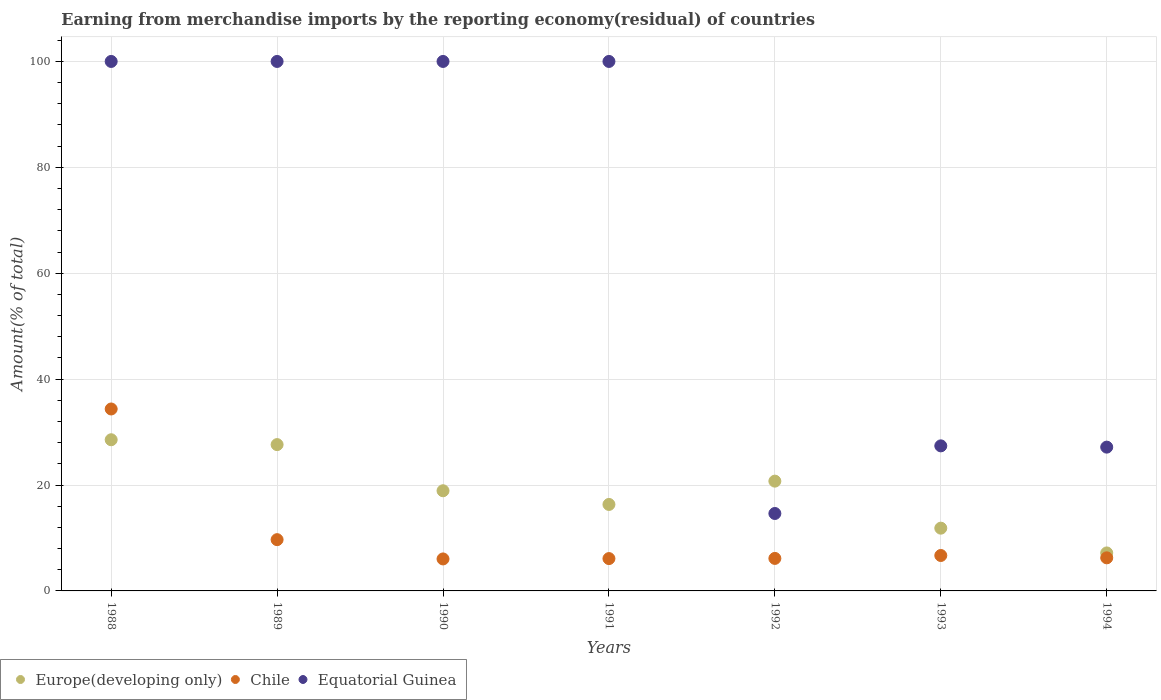How many different coloured dotlines are there?
Give a very brief answer. 3. Is the number of dotlines equal to the number of legend labels?
Offer a very short reply. Yes. What is the percentage of amount earned from merchandise imports in Europe(developing only) in 1993?
Offer a terse response. 11.85. Across all years, what is the maximum percentage of amount earned from merchandise imports in Chile?
Ensure brevity in your answer.  34.36. Across all years, what is the minimum percentage of amount earned from merchandise imports in Europe(developing only)?
Offer a terse response. 7.17. What is the total percentage of amount earned from merchandise imports in Europe(developing only) in the graph?
Keep it short and to the point. 131.2. What is the difference between the percentage of amount earned from merchandise imports in Equatorial Guinea in 1991 and that in 1994?
Offer a very short reply. 72.84. What is the difference between the percentage of amount earned from merchandise imports in Europe(developing only) in 1993 and the percentage of amount earned from merchandise imports in Chile in 1991?
Offer a terse response. 5.75. What is the average percentage of amount earned from merchandise imports in Equatorial Guinea per year?
Offer a very short reply. 67.03. In the year 1990, what is the difference between the percentage of amount earned from merchandise imports in Equatorial Guinea and percentage of amount earned from merchandise imports in Chile?
Provide a succinct answer. 93.96. What is the ratio of the percentage of amount earned from merchandise imports in Europe(developing only) in 1988 to that in 1991?
Ensure brevity in your answer.  1.75. Is the percentage of amount earned from merchandise imports in Europe(developing only) in 1989 less than that in 1993?
Offer a terse response. No. What is the difference between the highest and the second highest percentage of amount earned from merchandise imports in Chile?
Your answer should be compact. 24.68. What is the difference between the highest and the lowest percentage of amount earned from merchandise imports in Chile?
Give a very brief answer. 28.32. In how many years, is the percentage of amount earned from merchandise imports in Europe(developing only) greater than the average percentage of amount earned from merchandise imports in Europe(developing only) taken over all years?
Keep it short and to the point. 4. Is the sum of the percentage of amount earned from merchandise imports in Europe(developing only) in 1988 and 1991 greater than the maximum percentage of amount earned from merchandise imports in Equatorial Guinea across all years?
Provide a succinct answer. No. Is it the case that in every year, the sum of the percentage of amount earned from merchandise imports in Europe(developing only) and percentage of amount earned from merchandise imports in Equatorial Guinea  is greater than the percentage of amount earned from merchandise imports in Chile?
Offer a very short reply. Yes. Does the percentage of amount earned from merchandise imports in Equatorial Guinea monotonically increase over the years?
Ensure brevity in your answer.  No. How many dotlines are there?
Your answer should be very brief. 3. How many years are there in the graph?
Your answer should be very brief. 7. Where does the legend appear in the graph?
Provide a succinct answer. Bottom left. How are the legend labels stacked?
Provide a short and direct response. Horizontal. What is the title of the graph?
Your answer should be compact. Earning from merchandise imports by the reporting economy(residual) of countries. Does "Lithuania" appear as one of the legend labels in the graph?
Provide a succinct answer. No. What is the label or title of the Y-axis?
Your response must be concise. Amount(% of total). What is the Amount(% of total) in Europe(developing only) in 1988?
Provide a succinct answer. 28.55. What is the Amount(% of total) of Chile in 1988?
Provide a short and direct response. 34.36. What is the Amount(% of total) in Equatorial Guinea in 1988?
Your answer should be compact. 100. What is the Amount(% of total) of Europe(developing only) in 1989?
Your response must be concise. 27.64. What is the Amount(% of total) in Chile in 1989?
Your answer should be compact. 9.68. What is the Amount(% of total) of Equatorial Guinea in 1989?
Offer a terse response. 100. What is the Amount(% of total) of Europe(developing only) in 1990?
Provide a succinct answer. 18.92. What is the Amount(% of total) in Chile in 1990?
Your answer should be compact. 6.04. What is the Amount(% of total) in Equatorial Guinea in 1990?
Give a very brief answer. 100. What is the Amount(% of total) in Europe(developing only) in 1991?
Offer a terse response. 16.33. What is the Amount(% of total) of Chile in 1991?
Your answer should be compact. 6.11. What is the Amount(% of total) in Europe(developing only) in 1992?
Your answer should be compact. 20.73. What is the Amount(% of total) of Chile in 1992?
Keep it short and to the point. 6.14. What is the Amount(% of total) in Equatorial Guinea in 1992?
Provide a short and direct response. 14.62. What is the Amount(% of total) in Europe(developing only) in 1993?
Keep it short and to the point. 11.85. What is the Amount(% of total) in Chile in 1993?
Make the answer very short. 6.69. What is the Amount(% of total) of Equatorial Guinea in 1993?
Your answer should be compact. 27.4. What is the Amount(% of total) in Europe(developing only) in 1994?
Keep it short and to the point. 7.17. What is the Amount(% of total) of Chile in 1994?
Provide a short and direct response. 6.25. What is the Amount(% of total) in Equatorial Guinea in 1994?
Keep it short and to the point. 27.16. Across all years, what is the maximum Amount(% of total) of Europe(developing only)?
Ensure brevity in your answer.  28.55. Across all years, what is the maximum Amount(% of total) of Chile?
Give a very brief answer. 34.36. Across all years, what is the maximum Amount(% of total) of Equatorial Guinea?
Provide a short and direct response. 100. Across all years, what is the minimum Amount(% of total) of Europe(developing only)?
Your response must be concise. 7.17. Across all years, what is the minimum Amount(% of total) of Chile?
Your response must be concise. 6.04. Across all years, what is the minimum Amount(% of total) in Equatorial Guinea?
Give a very brief answer. 14.62. What is the total Amount(% of total) of Europe(developing only) in the graph?
Your answer should be very brief. 131.2. What is the total Amount(% of total) in Chile in the graph?
Keep it short and to the point. 75.27. What is the total Amount(% of total) in Equatorial Guinea in the graph?
Provide a succinct answer. 469.18. What is the difference between the Amount(% of total) of Europe(developing only) in 1988 and that in 1989?
Provide a short and direct response. 0.92. What is the difference between the Amount(% of total) of Chile in 1988 and that in 1989?
Make the answer very short. 24.68. What is the difference between the Amount(% of total) of Equatorial Guinea in 1988 and that in 1989?
Provide a short and direct response. 0. What is the difference between the Amount(% of total) of Europe(developing only) in 1988 and that in 1990?
Offer a very short reply. 9.63. What is the difference between the Amount(% of total) in Chile in 1988 and that in 1990?
Offer a terse response. 28.32. What is the difference between the Amount(% of total) in Europe(developing only) in 1988 and that in 1991?
Offer a very short reply. 12.22. What is the difference between the Amount(% of total) in Chile in 1988 and that in 1991?
Offer a very short reply. 28.25. What is the difference between the Amount(% of total) in Equatorial Guinea in 1988 and that in 1991?
Your answer should be very brief. 0. What is the difference between the Amount(% of total) of Europe(developing only) in 1988 and that in 1992?
Provide a short and direct response. 7.82. What is the difference between the Amount(% of total) of Chile in 1988 and that in 1992?
Your answer should be compact. 28.22. What is the difference between the Amount(% of total) in Equatorial Guinea in 1988 and that in 1992?
Ensure brevity in your answer.  85.38. What is the difference between the Amount(% of total) in Europe(developing only) in 1988 and that in 1993?
Your response must be concise. 16.7. What is the difference between the Amount(% of total) in Chile in 1988 and that in 1993?
Make the answer very short. 27.67. What is the difference between the Amount(% of total) of Equatorial Guinea in 1988 and that in 1993?
Give a very brief answer. 72.6. What is the difference between the Amount(% of total) of Europe(developing only) in 1988 and that in 1994?
Provide a succinct answer. 21.38. What is the difference between the Amount(% of total) of Chile in 1988 and that in 1994?
Your response must be concise. 28.11. What is the difference between the Amount(% of total) of Equatorial Guinea in 1988 and that in 1994?
Offer a very short reply. 72.84. What is the difference between the Amount(% of total) in Europe(developing only) in 1989 and that in 1990?
Offer a very short reply. 8.72. What is the difference between the Amount(% of total) in Chile in 1989 and that in 1990?
Keep it short and to the point. 3.64. What is the difference between the Amount(% of total) in Equatorial Guinea in 1989 and that in 1990?
Offer a terse response. 0. What is the difference between the Amount(% of total) in Europe(developing only) in 1989 and that in 1991?
Offer a terse response. 11.3. What is the difference between the Amount(% of total) of Chile in 1989 and that in 1991?
Your answer should be very brief. 3.58. What is the difference between the Amount(% of total) in Europe(developing only) in 1989 and that in 1992?
Provide a short and direct response. 6.9. What is the difference between the Amount(% of total) in Chile in 1989 and that in 1992?
Offer a terse response. 3.54. What is the difference between the Amount(% of total) in Equatorial Guinea in 1989 and that in 1992?
Make the answer very short. 85.38. What is the difference between the Amount(% of total) in Europe(developing only) in 1989 and that in 1993?
Provide a short and direct response. 15.78. What is the difference between the Amount(% of total) in Chile in 1989 and that in 1993?
Your answer should be very brief. 2.99. What is the difference between the Amount(% of total) in Equatorial Guinea in 1989 and that in 1993?
Your answer should be very brief. 72.6. What is the difference between the Amount(% of total) in Europe(developing only) in 1989 and that in 1994?
Your response must be concise. 20.46. What is the difference between the Amount(% of total) of Chile in 1989 and that in 1994?
Your answer should be compact. 3.43. What is the difference between the Amount(% of total) in Equatorial Guinea in 1989 and that in 1994?
Your answer should be very brief. 72.84. What is the difference between the Amount(% of total) of Europe(developing only) in 1990 and that in 1991?
Provide a succinct answer. 2.59. What is the difference between the Amount(% of total) of Chile in 1990 and that in 1991?
Offer a very short reply. -0.07. What is the difference between the Amount(% of total) of Equatorial Guinea in 1990 and that in 1991?
Offer a terse response. 0. What is the difference between the Amount(% of total) in Europe(developing only) in 1990 and that in 1992?
Ensure brevity in your answer.  -1.82. What is the difference between the Amount(% of total) in Chile in 1990 and that in 1992?
Keep it short and to the point. -0.1. What is the difference between the Amount(% of total) in Equatorial Guinea in 1990 and that in 1992?
Your response must be concise. 85.38. What is the difference between the Amount(% of total) in Europe(developing only) in 1990 and that in 1993?
Keep it short and to the point. 7.06. What is the difference between the Amount(% of total) in Chile in 1990 and that in 1993?
Ensure brevity in your answer.  -0.65. What is the difference between the Amount(% of total) of Equatorial Guinea in 1990 and that in 1993?
Your response must be concise. 72.6. What is the difference between the Amount(% of total) of Europe(developing only) in 1990 and that in 1994?
Your answer should be very brief. 11.74. What is the difference between the Amount(% of total) in Chile in 1990 and that in 1994?
Provide a short and direct response. -0.21. What is the difference between the Amount(% of total) of Equatorial Guinea in 1990 and that in 1994?
Offer a very short reply. 72.84. What is the difference between the Amount(% of total) of Europe(developing only) in 1991 and that in 1992?
Your answer should be compact. -4.4. What is the difference between the Amount(% of total) in Chile in 1991 and that in 1992?
Offer a terse response. -0.03. What is the difference between the Amount(% of total) in Equatorial Guinea in 1991 and that in 1992?
Give a very brief answer. 85.38. What is the difference between the Amount(% of total) in Europe(developing only) in 1991 and that in 1993?
Give a very brief answer. 4.48. What is the difference between the Amount(% of total) of Chile in 1991 and that in 1993?
Your answer should be compact. -0.58. What is the difference between the Amount(% of total) in Equatorial Guinea in 1991 and that in 1993?
Provide a succinct answer. 72.6. What is the difference between the Amount(% of total) of Europe(developing only) in 1991 and that in 1994?
Offer a terse response. 9.16. What is the difference between the Amount(% of total) in Chile in 1991 and that in 1994?
Offer a terse response. -0.14. What is the difference between the Amount(% of total) of Equatorial Guinea in 1991 and that in 1994?
Your response must be concise. 72.84. What is the difference between the Amount(% of total) of Europe(developing only) in 1992 and that in 1993?
Offer a terse response. 8.88. What is the difference between the Amount(% of total) of Chile in 1992 and that in 1993?
Provide a short and direct response. -0.55. What is the difference between the Amount(% of total) in Equatorial Guinea in 1992 and that in 1993?
Offer a very short reply. -12.77. What is the difference between the Amount(% of total) in Europe(developing only) in 1992 and that in 1994?
Provide a succinct answer. 13.56. What is the difference between the Amount(% of total) in Chile in 1992 and that in 1994?
Keep it short and to the point. -0.11. What is the difference between the Amount(% of total) in Equatorial Guinea in 1992 and that in 1994?
Give a very brief answer. -12.53. What is the difference between the Amount(% of total) of Europe(developing only) in 1993 and that in 1994?
Offer a terse response. 4.68. What is the difference between the Amount(% of total) in Chile in 1993 and that in 1994?
Your answer should be very brief. 0.44. What is the difference between the Amount(% of total) in Equatorial Guinea in 1993 and that in 1994?
Make the answer very short. 0.24. What is the difference between the Amount(% of total) of Europe(developing only) in 1988 and the Amount(% of total) of Chile in 1989?
Your answer should be very brief. 18.87. What is the difference between the Amount(% of total) in Europe(developing only) in 1988 and the Amount(% of total) in Equatorial Guinea in 1989?
Give a very brief answer. -71.45. What is the difference between the Amount(% of total) of Chile in 1988 and the Amount(% of total) of Equatorial Guinea in 1989?
Offer a terse response. -65.64. What is the difference between the Amount(% of total) in Europe(developing only) in 1988 and the Amount(% of total) in Chile in 1990?
Your answer should be compact. 22.51. What is the difference between the Amount(% of total) in Europe(developing only) in 1988 and the Amount(% of total) in Equatorial Guinea in 1990?
Ensure brevity in your answer.  -71.45. What is the difference between the Amount(% of total) in Chile in 1988 and the Amount(% of total) in Equatorial Guinea in 1990?
Offer a very short reply. -65.64. What is the difference between the Amount(% of total) of Europe(developing only) in 1988 and the Amount(% of total) of Chile in 1991?
Offer a very short reply. 22.44. What is the difference between the Amount(% of total) of Europe(developing only) in 1988 and the Amount(% of total) of Equatorial Guinea in 1991?
Keep it short and to the point. -71.45. What is the difference between the Amount(% of total) of Chile in 1988 and the Amount(% of total) of Equatorial Guinea in 1991?
Offer a terse response. -65.64. What is the difference between the Amount(% of total) in Europe(developing only) in 1988 and the Amount(% of total) in Chile in 1992?
Keep it short and to the point. 22.41. What is the difference between the Amount(% of total) in Europe(developing only) in 1988 and the Amount(% of total) in Equatorial Guinea in 1992?
Give a very brief answer. 13.93. What is the difference between the Amount(% of total) in Chile in 1988 and the Amount(% of total) in Equatorial Guinea in 1992?
Provide a succinct answer. 19.74. What is the difference between the Amount(% of total) of Europe(developing only) in 1988 and the Amount(% of total) of Chile in 1993?
Provide a short and direct response. 21.86. What is the difference between the Amount(% of total) of Europe(developing only) in 1988 and the Amount(% of total) of Equatorial Guinea in 1993?
Your answer should be very brief. 1.16. What is the difference between the Amount(% of total) in Chile in 1988 and the Amount(% of total) in Equatorial Guinea in 1993?
Offer a very short reply. 6.97. What is the difference between the Amount(% of total) of Europe(developing only) in 1988 and the Amount(% of total) of Chile in 1994?
Provide a succinct answer. 22.3. What is the difference between the Amount(% of total) in Europe(developing only) in 1988 and the Amount(% of total) in Equatorial Guinea in 1994?
Provide a short and direct response. 1.39. What is the difference between the Amount(% of total) in Chile in 1988 and the Amount(% of total) in Equatorial Guinea in 1994?
Provide a succinct answer. 7.2. What is the difference between the Amount(% of total) in Europe(developing only) in 1989 and the Amount(% of total) in Chile in 1990?
Keep it short and to the point. 21.59. What is the difference between the Amount(% of total) in Europe(developing only) in 1989 and the Amount(% of total) in Equatorial Guinea in 1990?
Your response must be concise. -72.36. What is the difference between the Amount(% of total) of Chile in 1989 and the Amount(% of total) of Equatorial Guinea in 1990?
Provide a succinct answer. -90.32. What is the difference between the Amount(% of total) in Europe(developing only) in 1989 and the Amount(% of total) in Chile in 1991?
Offer a very short reply. 21.53. What is the difference between the Amount(% of total) in Europe(developing only) in 1989 and the Amount(% of total) in Equatorial Guinea in 1991?
Offer a very short reply. -72.36. What is the difference between the Amount(% of total) in Chile in 1989 and the Amount(% of total) in Equatorial Guinea in 1991?
Provide a succinct answer. -90.32. What is the difference between the Amount(% of total) in Europe(developing only) in 1989 and the Amount(% of total) in Chile in 1992?
Give a very brief answer. 21.5. What is the difference between the Amount(% of total) in Europe(developing only) in 1989 and the Amount(% of total) in Equatorial Guinea in 1992?
Keep it short and to the point. 13.01. What is the difference between the Amount(% of total) of Chile in 1989 and the Amount(% of total) of Equatorial Guinea in 1992?
Give a very brief answer. -4.94. What is the difference between the Amount(% of total) in Europe(developing only) in 1989 and the Amount(% of total) in Chile in 1993?
Keep it short and to the point. 20.94. What is the difference between the Amount(% of total) in Europe(developing only) in 1989 and the Amount(% of total) in Equatorial Guinea in 1993?
Give a very brief answer. 0.24. What is the difference between the Amount(% of total) in Chile in 1989 and the Amount(% of total) in Equatorial Guinea in 1993?
Your answer should be very brief. -17.71. What is the difference between the Amount(% of total) of Europe(developing only) in 1989 and the Amount(% of total) of Chile in 1994?
Make the answer very short. 21.39. What is the difference between the Amount(% of total) in Europe(developing only) in 1989 and the Amount(% of total) in Equatorial Guinea in 1994?
Ensure brevity in your answer.  0.48. What is the difference between the Amount(% of total) of Chile in 1989 and the Amount(% of total) of Equatorial Guinea in 1994?
Provide a succinct answer. -17.47. What is the difference between the Amount(% of total) of Europe(developing only) in 1990 and the Amount(% of total) of Chile in 1991?
Your answer should be very brief. 12.81. What is the difference between the Amount(% of total) in Europe(developing only) in 1990 and the Amount(% of total) in Equatorial Guinea in 1991?
Provide a succinct answer. -81.08. What is the difference between the Amount(% of total) of Chile in 1990 and the Amount(% of total) of Equatorial Guinea in 1991?
Provide a succinct answer. -93.96. What is the difference between the Amount(% of total) in Europe(developing only) in 1990 and the Amount(% of total) in Chile in 1992?
Offer a terse response. 12.78. What is the difference between the Amount(% of total) of Europe(developing only) in 1990 and the Amount(% of total) of Equatorial Guinea in 1992?
Give a very brief answer. 4.29. What is the difference between the Amount(% of total) in Chile in 1990 and the Amount(% of total) in Equatorial Guinea in 1992?
Give a very brief answer. -8.58. What is the difference between the Amount(% of total) in Europe(developing only) in 1990 and the Amount(% of total) in Chile in 1993?
Offer a very short reply. 12.23. What is the difference between the Amount(% of total) of Europe(developing only) in 1990 and the Amount(% of total) of Equatorial Guinea in 1993?
Offer a very short reply. -8.48. What is the difference between the Amount(% of total) of Chile in 1990 and the Amount(% of total) of Equatorial Guinea in 1993?
Provide a succinct answer. -21.35. What is the difference between the Amount(% of total) in Europe(developing only) in 1990 and the Amount(% of total) in Chile in 1994?
Offer a terse response. 12.67. What is the difference between the Amount(% of total) in Europe(developing only) in 1990 and the Amount(% of total) in Equatorial Guinea in 1994?
Ensure brevity in your answer.  -8.24. What is the difference between the Amount(% of total) in Chile in 1990 and the Amount(% of total) in Equatorial Guinea in 1994?
Provide a short and direct response. -21.12. What is the difference between the Amount(% of total) of Europe(developing only) in 1991 and the Amount(% of total) of Chile in 1992?
Keep it short and to the point. 10.19. What is the difference between the Amount(% of total) in Europe(developing only) in 1991 and the Amount(% of total) in Equatorial Guinea in 1992?
Make the answer very short. 1.71. What is the difference between the Amount(% of total) in Chile in 1991 and the Amount(% of total) in Equatorial Guinea in 1992?
Your answer should be very brief. -8.52. What is the difference between the Amount(% of total) in Europe(developing only) in 1991 and the Amount(% of total) in Chile in 1993?
Your answer should be compact. 9.64. What is the difference between the Amount(% of total) of Europe(developing only) in 1991 and the Amount(% of total) of Equatorial Guinea in 1993?
Keep it short and to the point. -11.06. What is the difference between the Amount(% of total) of Chile in 1991 and the Amount(% of total) of Equatorial Guinea in 1993?
Your response must be concise. -21.29. What is the difference between the Amount(% of total) in Europe(developing only) in 1991 and the Amount(% of total) in Chile in 1994?
Give a very brief answer. 10.08. What is the difference between the Amount(% of total) in Europe(developing only) in 1991 and the Amount(% of total) in Equatorial Guinea in 1994?
Your answer should be compact. -10.82. What is the difference between the Amount(% of total) of Chile in 1991 and the Amount(% of total) of Equatorial Guinea in 1994?
Your answer should be very brief. -21.05. What is the difference between the Amount(% of total) of Europe(developing only) in 1992 and the Amount(% of total) of Chile in 1993?
Offer a terse response. 14.04. What is the difference between the Amount(% of total) in Europe(developing only) in 1992 and the Amount(% of total) in Equatorial Guinea in 1993?
Make the answer very short. -6.66. What is the difference between the Amount(% of total) in Chile in 1992 and the Amount(% of total) in Equatorial Guinea in 1993?
Offer a very short reply. -21.26. What is the difference between the Amount(% of total) in Europe(developing only) in 1992 and the Amount(% of total) in Chile in 1994?
Keep it short and to the point. 14.48. What is the difference between the Amount(% of total) in Europe(developing only) in 1992 and the Amount(% of total) in Equatorial Guinea in 1994?
Offer a very short reply. -6.42. What is the difference between the Amount(% of total) in Chile in 1992 and the Amount(% of total) in Equatorial Guinea in 1994?
Offer a very short reply. -21.02. What is the difference between the Amount(% of total) in Europe(developing only) in 1993 and the Amount(% of total) in Chile in 1994?
Your answer should be compact. 5.6. What is the difference between the Amount(% of total) in Europe(developing only) in 1993 and the Amount(% of total) in Equatorial Guinea in 1994?
Keep it short and to the point. -15.3. What is the difference between the Amount(% of total) in Chile in 1993 and the Amount(% of total) in Equatorial Guinea in 1994?
Provide a short and direct response. -20.47. What is the average Amount(% of total) in Europe(developing only) per year?
Make the answer very short. 18.74. What is the average Amount(% of total) in Chile per year?
Your answer should be very brief. 10.75. What is the average Amount(% of total) in Equatorial Guinea per year?
Make the answer very short. 67.03. In the year 1988, what is the difference between the Amount(% of total) of Europe(developing only) and Amount(% of total) of Chile?
Your answer should be compact. -5.81. In the year 1988, what is the difference between the Amount(% of total) of Europe(developing only) and Amount(% of total) of Equatorial Guinea?
Your response must be concise. -71.45. In the year 1988, what is the difference between the Amount(% of total) of Chile and Amount(% of total) of Equatorial Guinea?
Ensure brevity in your answer.  -65.64. In the year 1989, what is the difference between the Amount(% of total) in Europe(developing only) and Amount(% of total) in Chile?
Provide a short and direct response. 17.95. In the year 1989, what is the difference between the Amount(% of total) of Europe(developing only) and Amount(% of total) of Equatorial Guinea?
Provide a short and direct response. -72.36. In the year 1989, what is the difference between the Amount(% of total) of Chile and Amount(% of total) of Equatorial Guinea?
Offer a very short reply. -90.32. In the year 1990, what is the difference between the Amount(% of total) of Europe(developing only) and Amount(% of total) of Chile?
Give a very brief answer. 12.88. In the year 1990, what is the difference between the Amount(% of total) in Europe(developing only) and Amount(% of total) in Equatorial Guinea?
Keep it short and to the point. -81.08. In the year 1990, what is the difference between the Amount(% of total) of Chile and Amount(% of total) of Equatorial Guinea?
Ensure brevity in your answer.  -93.96. In the year 1991, what is the difference between the Amount(% of total) in Europe(developing only) and Amount(% of total) in Chile?
Offer a terse response. 10.22. In the year 1991, what is the difference between the Amount(% of total) of Europe(developing only) and Amount(% of total) of Equatorial Guinea?
Give a very brief answer. -83.67. In the year 1991, what is the difference between the Amount(% of total) in Chile and Amount(% of total) in Equatorial Guinea?
Ensure brevity in your answer.  -93.89. In the year 1992, what is the difference between the Amount(% of total) of Europe(developing only) and Amount(% of total) of Chile?
Ensure brevity in your answer.  14.59. In the year 1992, what is the difference between the Amount(% of total) of Europe(developing only) and Amount(% of total) of Equatorial Guinea?
Keep it short and to the point. 6.11. In the year 1992, what is the difference between the Amount(% of total) in Chile and Amount(% of total) in Equatorial Guinea?
Your answer should be compact. -8.48. In the year 1993, what is the difference between the Amount(% of total) of Europe(developing only) and Amount(% of total) of Chile?
Give a very brief answer. 5.16. In the year 1993, what is the difference between the Amount(% of total) of Europe(developing only) and Amount(% of total) of Equatorial Guinea?
Offer a terse response. -15.54. In the year 1993, what is the difference between the Amount(% of total) in Chile and Amount(% of total) in Equatorial Guinea?
Your answer should be very brief. -20.71. In the year 1994, what is the difference between the Amount(% of total) of Europe(developing only) and Amount(% of total) of Chile?
Offer a terse response. 0.93. In the year 1994, what is the difference between the Amount(% of total) of Europe(developing only) and Amount(% of total) of Equatorial Guinea?
Give a very brief answer. -19.98. In the year 1994, what is the difference between the Amount(% of total) of Chile and Amount(% of total) of Equatorial Guinea?
Provide a succinct answer. -20.91. What is the ratio of the Amount(% of total) of Europe(developing only) in 1988 to that in 1989?
Provide a short and direct response. 1.03. What is the ratio of the Amount(% of total) of Chile in 1988 to that in 1989?
Your answer should be compact. 3.55. What is the ratio of the Amount(% of total) in Equatorial Guinea in 1988 to that in 1989?
Provide a succinct answer. 1. What is the ratio of the Amount(% of total) in Europe(developing only) in 1988 to that in 1990?
Your response must be concise. 1.51. What is the ratio of the Amount(% of total) in Chile in 1988 to that in 1990?
Offer a terse response. 5.69. What is the ratio of the Amount(% of total) of Equatorial Guinea in 1988 to that in 1990?
Provide a succinct answer. 1. What is the ratio of the Amount(% of total) of Europe(developing only) in 1988 to that in 1991?
Offer a terse response. 1.75. What is the ratio of the Amount(% of total) of Chile in 1988 to that in 1991?
Your response must be concise. 5.63. What is the ratio of the Amount(% of total) of Equatorial Guinea in 1988 to that in 1991?
Your answer should be compact. 1. What is the ratio of the Amount(% of total) of Europe(developing only) in 1988 to that in 1992?
Offer a very short reply. 1.38. What is the ratio of the Amount(% of total) of Chile in 1988 to that in 1992?
Ensure brevity in your answer.  5.6. What is the ratio of the Amount(% of total) in Equatorial Guinea in 1988 to that in 1992?
Ensure brevity in your answer.  6.84. What is the ratio of the Amount(% of total) of Europe(developing only) in 1988 to that in 1993?
Offer a very short reply. 2.41. What is the ratio of the Amount(% of total) of Chile in 1988 to that in 1993?
Ensure brevity in your answer.  5.14. What is the ratio of the Amount(% of total) of Equatorial Guinea in 1988 to that in 1993?
Provide a short and direct response. 3.65. What is the ratio of the Amount(% of total) of Europe(developing only) in 1988 to that in 1994?
Ensure brevity in your answer.  3.98. What is the ratio of the Amount(% of total) in Chile in 1988 to that in 1994?
Give a very brief answer. 5.5. What is the ratio of the Amount(% of total) in Equatorial Guinea in 1988 to that in 1994?
Your answer should be compact. 3.68. What is the ratio of the Amount(% of total) of Europe(developing only) in 1989 to that in 1990?
Keep it short and to the point. 1.46. What is the ratio of the Amount(% of total) of Chile in 1989 to that in 1990?
Make the answer very short. 1.6. What is the ratio of the Amount(% of total) of Europe(developing only) in 1989 to that in 1991?
Your answer should be very brief. 1.69. What is the ratio of the Amount(% of total) in Chile in 1989 to that in 1991?
Give a very brief answer. 1.59. What is the ratio of the Amount(% of total) of Europe(developing only) in 1989 to that in 1992?
Ensure brevity in your answer.  1.33. What is the ratio of the Amount(% of total) of Chile in 1989 to that in 1992?
Your answer should be very brief. 1.58. What is the ratio of the Amount(% of total) of Equatorial Guinea in 1989 to that in 1992?
Offer a terse response. 6.84. What is the ratio of the Amount(% of total) in Europe(developing only) in 1989 to that in 1993?
Give a very brief answer. 2.33. What is the ratio of the Amount(% of total) in Chile in 1989 to that in 1993?
Your answer should be very brief. 1.45. What is the ratio of the Amount(% of total) of Equatorial Guinea in 1989 to that in 1993?
Provide a succinct answer. 3.65. What is the ratio of the Amount(% of total) of Europe(developing only) in 1989 to that in 1994?
Your response must be concise. 3.85. What is the ratio of the Amount(% of total) of Chile in 1989 to that in 1994?
Your answer should be compact. 1.55. What is the ratio of the Amount(% of total) in Equatorial Guinea in 1989 to that in 1994?
Provide a succinct answer. 3.68. What is the ratio of the Amount(% of total) in Europe(developing only) in 1990 to that in 1991?
Provide a succinct answer. 1.16. What is the ratio of the Amount(% of total) of Chile in 1990 to that in 1991?
Give a very brief answer. 0.99. What is the ratio of the Amount(% of total) in Europe(developing only) in 1990 to that in 1992?
Ensure brevity in your answer.  0.91. What is the ratio of the Amount(% of total) of Chile in 1990 to that in 1992?
Offer a very short reply. 0.98. What is the ratio of the Amount(% of total) in Equatorial Guinea in 1990 to that in 1992?
Your response must be concise. 6.84. What is the ratio of the Amount(% of total) of Europe(developing only) in 1990 to that in 1993?
Give a very brief answer. 1.6. What is the ratio of the Amount(% of total) in Chile in 1990 to that in 1993?
Your answer should be compact. 0.9. What is the ratio of the Amount(% of total) of Equatorial Guinea in 1990 to that in 1993?
Your response must be concise. 3.65. What is the ratio of the Amount(% of total) in Europe(developing only) in 1990 to that in 1994?
Your answer should be compact. 2.64. What is the ratio of the Amount(% of total) in Chile in 1990 to that in 1994?
Keep it short and to the point. 0.97. What is the ratio of the Amount(% of total) of Equatorial Guinea in 1990 to that in 1994?
Offer a terse response. 3.68. What is the ratio of the Amount(% of total) in Europe(developing only) in 1991 to that in 1992?
Provide a short and direct response. 0.79. What is the ratio of the Amount(% of total) of Chile in 1991 to that in 1992?
Provide a short and direct response. 0.99. What is the ratio of the Amount(% of total) of Equatorial Guinea in 1991 to that in 1992?
Offer a very short reply. 6.84. What is the ratio of the Amount(% of total) in Europe(developing only) in 1991 to that in 1993?
Your answer should be very brief. 1.38. What is the ratio of the Amount(% of total) of Chile in 1991 to that in 1993?
Provide a succinct answer. 0.91. What is the ratio of the Amount(% of total) of Equatorial Guinea in 1991 to that in 1993?
Your answer should be very brief. 3.65. What is the ratio of the Amount(% of total) of Europe(developing only) in 1991 to that in 1994?
Keep it short and to the point. 2.28. What is the ratio of the Amount(% of total) in Chile in 1991 to that in 1994?
Ensure brevity in your answer.  0.98. What is the ratio of the Amount(% of total) in Equatorial Guinea in 1991 to that in 1994?
Provide a short and direct response. 3.68. What is the ratio of the Amount(% of total) of Europe(developing only) in 1992 to that in 1993?
Offer a terse response. 1.75. What is the ratio of the Amount(% of total) of Chile in 1992 to that in 1993?
Offer a very short reply. 0.92. What is the ratio of the Amount(% of total) in Equatorial Guinea in 1992 to that in 1993?
Offer a very short reply. 0.53. What is the ratio of the Amount(% of total) of Europe(developing only) in 1992 to that in 1994?
Offer a very short reply. 2.89. What is the ratio of the Amount(% of total) in Chile in 1992 to that in 1994?
Give a very brief answer. 0.98. What is the ratio of the Amount(% of total) in Equatorial Guinea in 1992 to that in 1994?
Ensure brevity in your answer.  0.54. What is the ratio of the Amount(% of total) of Europe(developing only) in 1993 to that in 1994?
Keep it short and to the point. 1.65. What is the ratio of the Amount(% of total) in Chile in 1993 to that in 1994?
Give a very brief answer. 1.07. What is the ratio of the Amount(% of total) of Equatorial Guinea in 1993 to that in 1994?
Provide a short and direct response. 1.01. What is the difference between the highest and the second highest Amount(% of total) of Europe(developing only)?
Your answer should be very brief. 0.92. What is the difference between the highest and the second highest Amount(% of total) in Chile?
Make the answer very short. 24.68. What is the difference between the highest and the lowest Amount(% of total) of Europe(developing only)?
Your answer should be very brief. 21.38. What is the difference between the highest and the lowest Amount(% of total) in Chile?
Provide a short and direct response. 28.32. What is the difference between the highest and the lowest Amount(% of total) in Equatorial Guinea?
Your answer should be very brief. 85.38. 